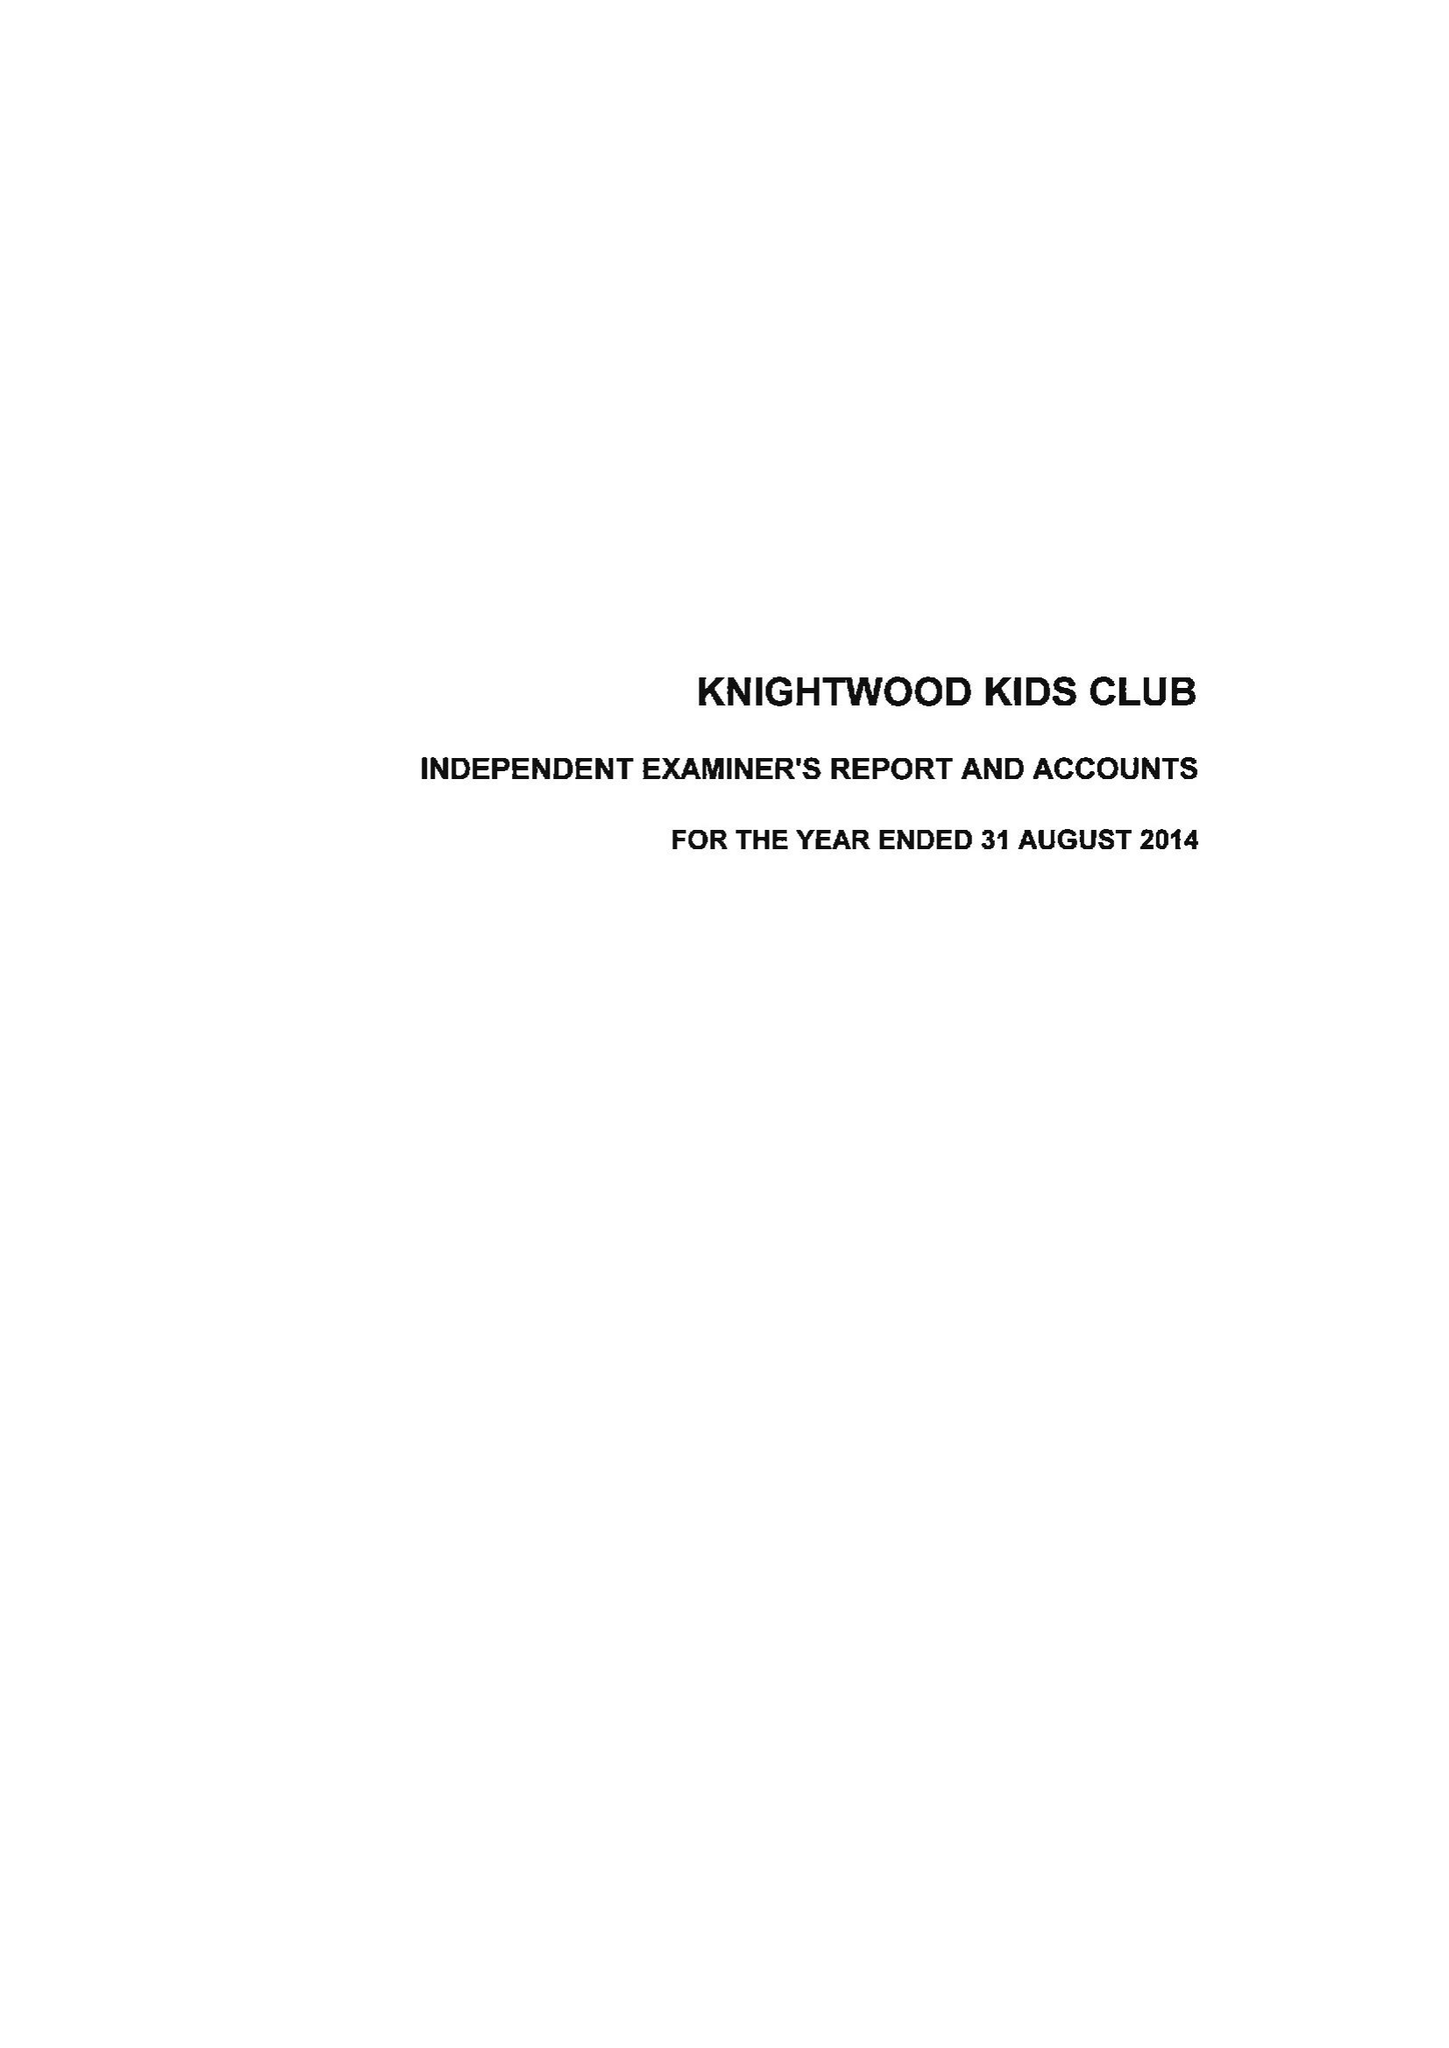What is the value for the income_annually_in_british_pounds?
Answer the question using a single word or phrase. 78983.00 